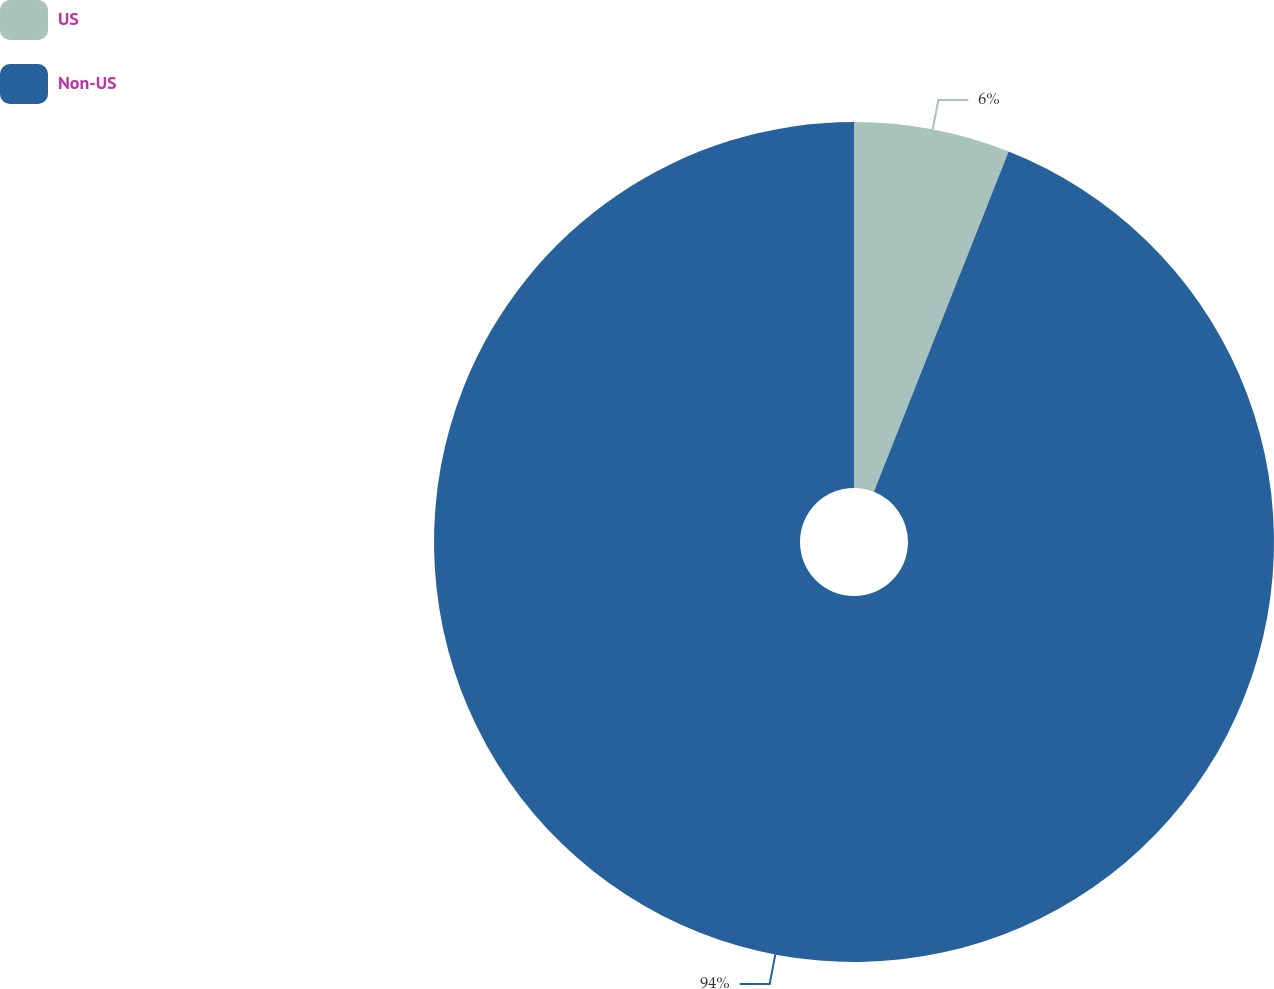Convert chart. <chart><loc_0><loc_0><loc_500><loc_500><pie_chart><fcel>US<fcel>Non-US<nl><fcel>6.0%<fcel>94.0%<nl></chart> 